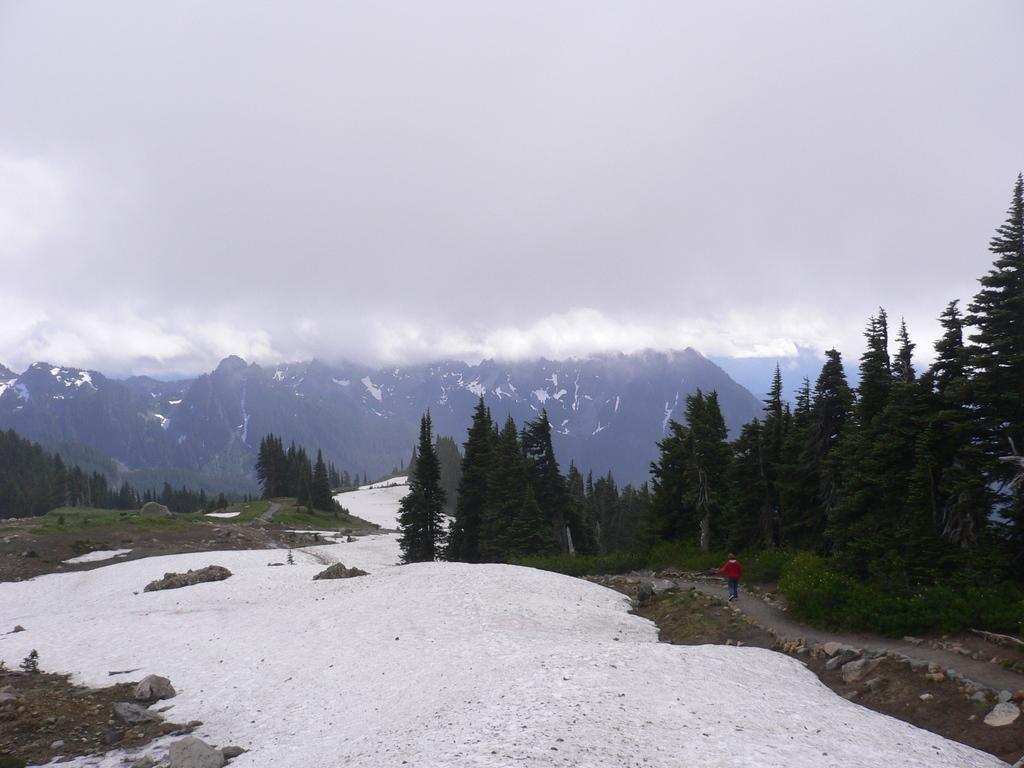What is located at the bottom of the image? There are trees, hills, and stones at the bottom of the image. What is happening in the middle of the image? A person is walking in the middle of the image. What is visible at the top of the image? There are hills, clouds, and the sky visible at the top of the image. How many rabbits can be observed in the image? There are no rabbits present in the image. What process is being carried out by the person in the image? The image does not provide enough information to determine the specific process being carried out by the person. 